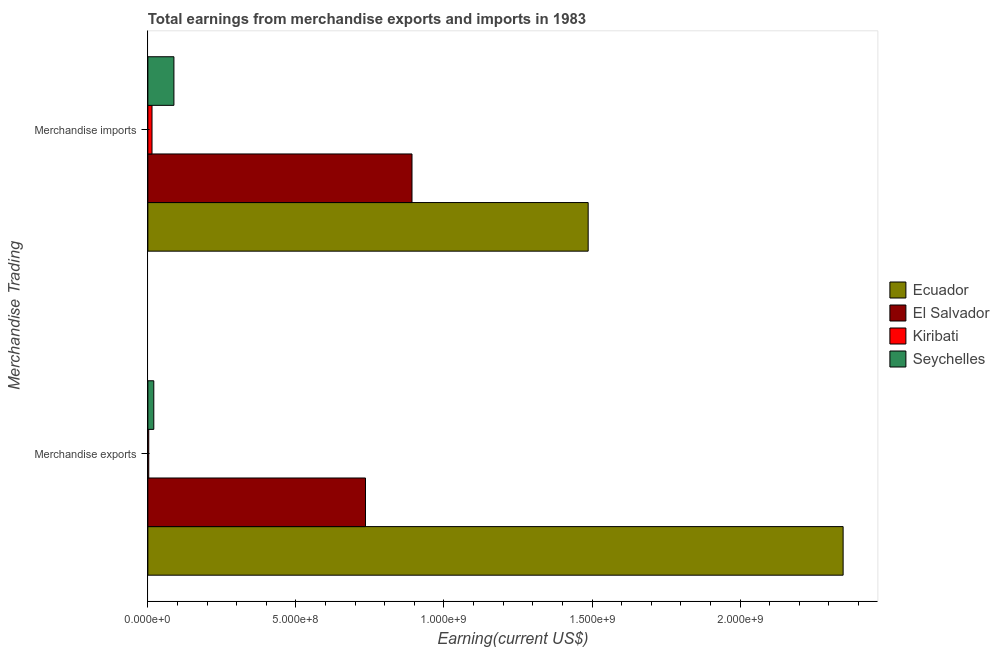How many different coloured bars are there?
Give a very brief answer. 4. How many groups of bars are there?
Your answer should be compact. 2. Are the number of bars on each tick of the Y-axis equal?
Keep it short and to the point. Yes. How many bars are there on the 1st tick from the bottom?
Ensure brevity in your answer.  4. What is the earnings from merchandise exports in El Salvador?
Your answer should be very brief. 7.35e+08. Across all countries, what is the maximum earnings from merchandise imports?
Provide a short and direct response. 1.49e+09. Across all countries, what is the minimum earnings from merchandise imports?
Make the answer very short. 1.40e+07. In which country was the earnings from merchandise exports maximum?
Offer a terse response. Ecuador. In which country was the earnings from merchandise exports minimum?
Provide a short and direct response. Kiribati. What is the total earnings from merchandise imports in the graph?
Offer a very short reply. 2.48e+09. What is the difference between the earnings from merchandise imports in Seychelles and that in El Salvador?
Your response must be concise. -8.04e+08. What is the difference between the earnings from merchandise exports in Seychelles and the earnings from merchandise imports in Kiribati?
Your answer should be very brief. 6.00e+06. What is the average earnings from merchandise exports per country?
Provide a short and direct response. 7.76e+08. What is the difference between the earnings from merchandise exports and earnings from merchandise imports in Ecuador?
Keep it short and to the point. 8.61e+08. What is the ratio of the earnings from merchandise exports in Ecuador to that in Seychelles?
Ensure brevity in your answer.  117.4. In how many countries, is the earnings from merchandise exports greater than the average earnings from merchandise exports taken over all countries?
Offer a terse response. 1. What does the 2nd bar from the top in Merchandise imports represents?
Your answer should be compact. Kiribati. What does the 3rd bar from the bottom in Merchandise exports represents?
Offer a very short reply. Kiribati. How many bars are there?
Provide a short and direct response. 8. How many countries are there in the graph?
Provide a succinct answer. 4. What is the difference between two consecutive major ticks on the X-axis?
Give a very brief answer. 5.00e+08. Are the values on the major ticks of X-axis written in scientific E-notation?
Your answer should be compact. Yes. How many legend labels are there?
Keep it short and to the point. 4. What is the title of the graph?
Your answer should be compact. Total earnings from merchandise exports and imports in 1983. Does "Morocco" appear as one of the legend labels in the graph?
Give a very brief answer. No. What is the label or title of the X-axis?
Ensure brevity in your answer.  Earning(current US$). What is the label or title of the Y-axis?
Offer a terse response. Merchandise Trading. What is the Earning(current US$) of Ecuador in Merchandise exports?
Provide a succinct answer. 2.35e+09. What is the Earning(current US$) in El Salvador in Merchandise exports?
Provide a short and direct response. 7.35e+08. What is the Earning(current US$) in Seychelles in Merchandise exports?
Keep it short and to the point. 2.00e+07. What is the Earning(current US$) of Ecuador in Merchandise imports?
Ensure brevity in your answer.  1.49e+09. What is the Earning(current US$) in El Salvador in Merchandise imports?
Provide a short and direct response. 8.92e+08. What is the Earning(current US$) in Kiribati in Merchandise imports?
Ensure brevity in your answer.  1.40e+07. What is the Earning(current US$) of Seychelles in Merchandise imports?
Ensure brevity in your answer.  8.80e+07. Across all Merchandise Trading, what is the maximum Earning(current US$) of Ecuador?
Make the answer very short. 2.35e+09. Across all Merchandise Trading, what is the maximum Earning(current US$) in El Salvador?
Your answer should be compact. 8.92e+08. Across all Merchandise Trading, what is the maximum Earning(current US$) in Kiribati?
Make the answer very short. 1.40e+07. Across all Merchandise Trading, what is the maximum Earning(current US$) of Seychelles?
Your answer should be compact. 8.80e+07. Across all Merchandise Trading, what is the minimum Earning(current US$) of Ecuador?
Ensure brevity in your answer.  1.49e+09. Across all Merchandise Trading, what is the minimum Earning(current US$) of El Salvador?
Give a very brief answer. 7.35e+08. Across all Merchandise Trading, what is the minimum Earning(current US$) in Kiribati?
Make the answer very short. 3.00e+06. What is the total Earning(current US$) of Ecuador in the graph?
Provide a succinct answer. 3.84e+09. What is the total Earning(current US$) in El Salvador in the graph?
Provide a short and direct response. 1.63e+09. What is the total Earning(current US$) in Kiribati in the graph?
Keep it short and to the point. 1.70e+07. What is the total Earning(current US$) in Seychelles in the graph?
Provide a succinct answer. 1.08e+08. What is the difference between the Earning(current US$) of Ecuador in Merchandise exports and that in Merchandise imports?
Provide a succinct answer. 8.61e+08. What is the difference between the Earning(current US$) in El Salvador in Merchandise exports and that in Merchandise imports?
Give a very brief answer. -1.57e+08. What is the difference between the Earning(current US$) in Kiribati in Merchandise exports and that in Merchandise imports?
Your response must be concise. -1.10e+07. What is the difference between the Earning(current US$) of Seychelles in Merchandise exports and that in Merchandise imports?
Give a very brief answer. -6.80e+07. What is the difference between the Earning(current US$) in Ecuador in Merchandise exports and the Earning(current US$) in El Salvador in Merchandise imports?
Provide a short and direct response. 1.46e+09. What is the difference between the Earning(current US$) of Ecuador in Merchandise exports and the Earning(current US$) of Kiribati in Merchandise imports?
Ensure brevity in your answer.  2.33e+09. What is the difference between the Earning(current US$) in Ecuador in Merchandise exports and the Earning(current US$) in Seychelles in Merchandise imports?
Your answer should be compact. 2.26e+09. What is the difference between the Earning(current US$) in El Salvador in Merchandise exports and the Earning(current US$) in Kiribati in Merchandise imports?
Keep it short and to the point. 7.21e+08. What is the difference between the Earning(current US$) in El Salvador in Merchandise exports and the Earning(current US$) in Seychelles in Merchandise imports?
Keep it short and to the point. 6.47e+08. What is the difference between the Earning(current US$) in Kiribati in Merchandise exports and the Earning(current US$) in Seychelles in Merchandise imports?
Your answer should be very brief. -8.50e+07. What is the average Earning(current US$) of Ecuador per Merchandise Trading?
Offer a terse response. 1.92e+09. What is the average Earning(current US$) of El Salvador per Merchandise Trading?
Your response must be concise. 8.14e+08. What is the average Earning(current US$) of Kiribati per Merchandise Trading?
Your answer should be compact. 8.50e+06. What is the average Earning(current US$) in Seychelles per Merchandise Trading?
Make the answer very short. 5.40e+07. What is the difference between the Earning(current US$) in Ecuador and Earning(current US$) in El Salvador in Merchandise exports?
Offer a terse response. 1.61e+09. What is the difference between the Earning(current US$) of Ecuador and Earning(current US$) of Kiribati in Merchandise exports?
Ensure brevity in your answer.  2.34e+09. What is the difference between the Earning(current US$) of Ecuador and Earning(current US$) of Seychelles in Merchandise exports?
Offer a terse response. 2.33e+09. What is the difference between the Earning(current US$) in El Salvador and Earning(current US$) in Kiribati in Merchandise exports?
Offer a very short reply. 7.32e+08. What is the difference between the Earning(current US$) in El Salvador and Earning(current US$) in Seychelles in Merchandise exports?
Your answer should be compact. 7.15e+08. What is the difference between the Earning(current US$) in Kiribati and Earning(current US$) in Seychelles in Merchandise exports?
Keep it short and to the point. -1.70e+07. What is the difference between the Earning(current US$) in Ecuador and Earning(current US$) in El Salvador in Merchandise imports?
Provide a succinct answer. 5.95e+08. What is the difference between the Earning(current US$) in Ecuador and Earning(current US$) in Kiribati in Merchandise imports?
Your answer should be very brief. 1.47e+09. What is the difference between the Earning(current US$) of Ecuador and Earning(current US$) of Seychelles in Merchandise imports?
Your answer should be compact. 1.40e+09. What is the difference between the Earning(current US$) in El Salvador and Earning(current US$) in Kiribati in Merchandise imports?
Your answer should be very brief. 8.78e+08. What is the difference between the Earning(current US$) in El Salvador and Earning(current US$) in Seychelles in Merchandise imports?
Your answer should be very brief. 8.04e+08. What is the difference between the Earning(current US$) in Kiribati and Earning(current US$) in Seychelles in Merchandise imports?
Provide a short and direct response. -7.40e+07. What is the ratio of the Earning(current US$) of Ecuador in Merchandise exports to that in Merchandise imports?
Provide a succinct answer. 1.58. What is the ratio of the Earning(current US$) of El Salvador in Merchandise exports to that in Merchandise imports?
Offer a very short reply. 0.82. What is the ratio of the Earning(current US$) of Kiribati in Merchandise exports to that in Merchandise imports?
Offer a very short reply. 0.21. What is the ratio of the Earning(current US$) in Seychelles in Merchandise exports to that in Merchandise imports?
Your answer should be very brief. 0.23. What is the difference between the highest and the second highest Earning(current US$) of Ecuador?
Make the answer very short. 8.61e+08. What is the difference between the highest and the second highest Earning(current US$) of El Salvador?
Provide a succinct answer. 1.57e+08. What is the difference between the highest and the second highest Earning(current US$) in Kiribati?
Your answer should be very brief. 1.10e+07. What is the difference between the highest and the second highest Earning(current US$) of Seychelles?
Your answer should be very brief. 6.80e+07. What is the difference between the highest and the lowest Earning(current US$) in Ecuador?
Your answer should be very brief. 8.61e+08. What is the difference between the highest and the lowest Earning(current US$) in El Salvador?
Make the answer very short. 1.57e+08. What is the difference between the highest and the lowest Earning(current US$) of Kiribati?
Give a very brief answer. 1.10e+07. What is the difference between the highest and the lowest Earning(current US$) in Seychelles?
Offer a very short reply. 6.80e+07. 